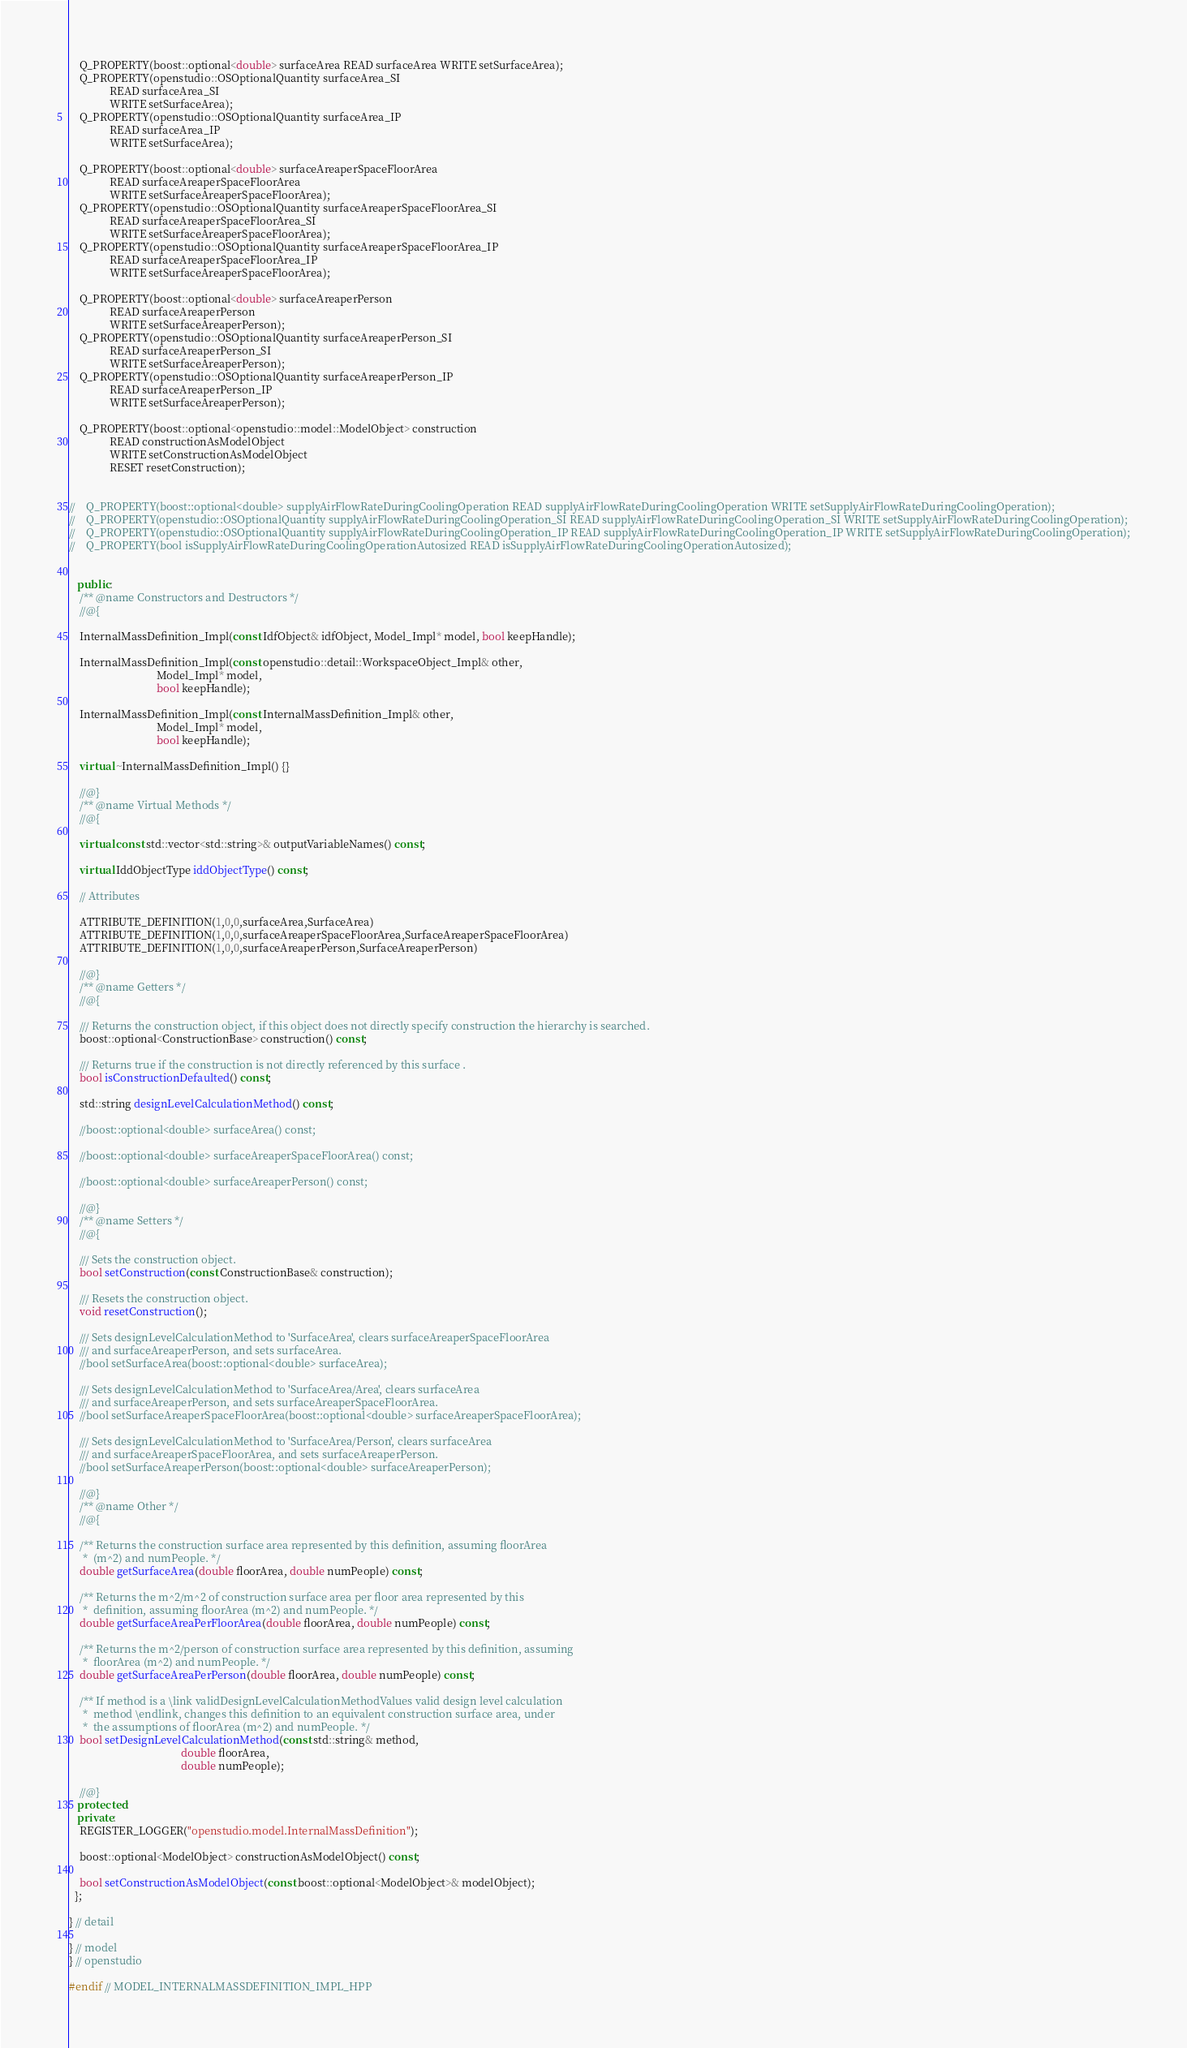Convert code to text. <code><loc_0><loc_0><loc_500><loc_500><_C++_>    Q_PROPERTY(boost::optional<double> surfaceArea READ surfaceArea WRITE setSurfaceArea);
    Q_PROPERTY(openstudio::OSOptionalQuantity surfaceArea_SI 
               READ surfaceArea_SI 
               WRITE setSurfaceArea);
    Q_PROPERTY(openstudio::OSOptionalQuantity surfaceArea_IP 
               READ surfaceArea_IP 
               WRITE setSurfaceArea);

    Q_PROPERTY(boost::optional<double> surfaceAreaperSpaceFloorArea 
               READ surfaceAreaperSpaceFloorArea 
               WRITE setSurfaceAreaperSpaceFloorArea);
    Q_PROPERTY(openstudio::OSOptionalQuantity surfaceAreaperSpaceFloorArea_SI 
               READ surfaceAreaperSpaceFloorArea_SI 
               WRITE setSurfaceAreaperSpaceFloorArea);
    Q_PROPERTY(openstudio::OSOptionalQuantity surfaceAreaperSpaceFloorArea_IP 
               READ surfaceAreaperSpaceFloorArea_IP 
               WRITE setSurfaceAreaperSpaceFloorArea);

    Q_PROPERTY(boost::optional<double> surfaceAreaperPerson 
               READ surfaceAreaperPerson 
               WRITE setSurfaceAreaperPerson);
    Q_PROPERTY(openstudio::OSOptionalQuantity surfaceAreaperPerson_SI 
               READ surfaceAreaperPerson_SI 
               WRITE setSurfaceAreaperPerson);
    Q_PROPERTY(openstudio::OSOptionalQuantity surfaceAreaperPerson_IP 
               READ surfaceAreaperPerson_IP 
               WRITE setSurfaceAreaperPerson);

    Q_PROPERTY(boost::optional<openstudio::model::ModelObject> construction 
               READ constructionAsModelObject 
               WRITE setConstructionAsModelObject 
               RESET resetConstruction);

 
//    Q_PROPERTY(boost::optional<double> supplyAirFlowRateDuringCoolingOperation READ supplyAirFlowRateDuringCoolingOperation WRITE setSupplyAirFlowRateDuringCoolingOperation);
//    Q_PROPERTY(openstudio::OSOptionalQuantity supplyAirFlowRateDuringCoolingOperation_SI READ supplyAirFlowRateDuringCoolingOperation_SI WRITE setSupplyAirFlowRateDuringCoolingOperation);
//    Q_PROPERTY(openstudio::OSOptionalQuantity supplyAirFlowRateDuringCoolingOperation_IP READ supplyAirFlowRateDuringCoolingOperation_IP WRITE setSupplyAirFlowRateDuringCoolingOperation);
//    Q_PROPERTY(bool isSupplyAirFlowRateDuringCoolingOperationAutosized READ isSupplyAirFlowRateDuringCoolingOperationAutosized);


   public:
    /** @name Constructors and Destructors */
    //@{

    InternalMassDefinition_Impl(const IdfObject& idfObject, Model_Impl* model, bool keepHandle);

    InternalMassDefinition_Impl(const openstudio::detail::WorkspaceObject_Impl& other,
                                Model_Impl* model,
                                bool keepHandle);

    InternalMassDefinition_Impl(const InternalMassDefinition_Impl& other,
                                Model_Impl* model,
                                bool keepHandle);

    virtual ~InternalMassDefinition_Impl() {}

    //@}
    /** @name Virtual Methods */
    //@{

    virtual const std::vector<std::string>& outputVariableNames() const;

    virtual IddObjectType iddObjectType() const;

    // Attributes

    ATTRIBUTE_DEFINITION(1,0,0,surfaceArea,SurfaceArea)
    ATTRIBUTE_DEFINITION(1,0,0,surfaceAreaperSpaceFloorArea,SurfaceAreaperSpaceFloorArea)
    ATTRIBUTE_DEFINITION(1,0,0,surfaceAreaperPerson,SurfaceAreaperPerson)

    //@}
    /** @name Getters */
    //@{

    /// Returns the construction object, if this object does not directly specify construction the hierarchy is searched.
    boost::optional<ConstructionBase> construction() const;

    /// Returns true if the construction is not directly referenced by this surface .
    bool isConstructionDefaulted() const;

    std::string designLevelCalculationMethod() const;

    //boost::optional<double> surfaceArea() const;

    //boost::optional<double> surfaceAreaperSpaceFloorArea() const;

    //boost::optional<double> surfaceAreaperPerson() const;

    //@}
    /** @name Setters */
    //@{

    /// Sets the construction object.
    bool setConstruction(const ConstructionBase& construction);

    /// Resets the construction object.
    void resetConstruction();

    /// Sets designLevelCalculationMethod to 'SurfaceArea', clears surfaceAreaperSpaceFloorArea
    /// and surfaceAreaperPerson, and sets surfaceArea.
    //bool setSurfaceArea(boost::optional<double> surfaceArea);

    /// Sets designLevelCalculationMethod to 'SurfaceArea/Area', clears surfaceArea
    /// and surfaceAreaperPerson, and sets surfaceAreaperSpaceFloorArea.
    //bool setSurfaceAreaperSpaceFloorArea(boost::optional<double> surfaceAreaperSpaceFloorArea);

    /// Sets designLevelCalculationMethod to 'SurfaceArea/Person', clears surfaceArea
    /// and surfaceAreaperSpaceFloorArea, and sets surfaceAreaperPerson.
    //bool setSurfaceAreaperPerson(boost::optional<double> surfaceAreaperPerson);

    //@}
    /** @name Other */
    //@{

    /** Returns the construction surface area represented by this definition, assuming floorArea 
     *  (m^2) and numPeople. */
    double getSurfaceArea(double floorArea, double numPeople) const;

    /** Returns the m^2/m^2 of construction surface area per floor area represented by this 
     *  definition, assuming floorArea (m^2) and numPeople. */
    double getSurfaceAreaPerFloorArea(double floorArea, double numPeople) const;

    /** Returns the m^2/person of construction surface area represented by this definition, assuming 
     *  floorArea (m^2) and numPeople. */
    double getSurfaceAreaPerPerson(double floorArea, double numPeople) const;

    /** If method is a \link validDesignLevelCalculationMethodValues valid design level calculation 
     *  method \endlink, changes this definition to an equivalent construction surface area, under 
     *  the assumptions of floorArea (m^2) and numPeople. */
    bool setDesignLevelCalculationMethod(const std::string& method,
                                         double floorArea,
                                         double numPeople);

    //@}
   protected:
   private:
    REGISTER_LOGGER("openstudio.model.InternalMassDefinition");

    boost::optional<ModelObject> constructionAsModelObject() const;

    bool setConstructionAsModelObject(const boost::optional<ModelObject>& modelObject);
  };

} // detail

} // model
} // openstudio

#endif // MODEL_INTERNALMASSDEFINITION_IMPL_HPP

</code> 